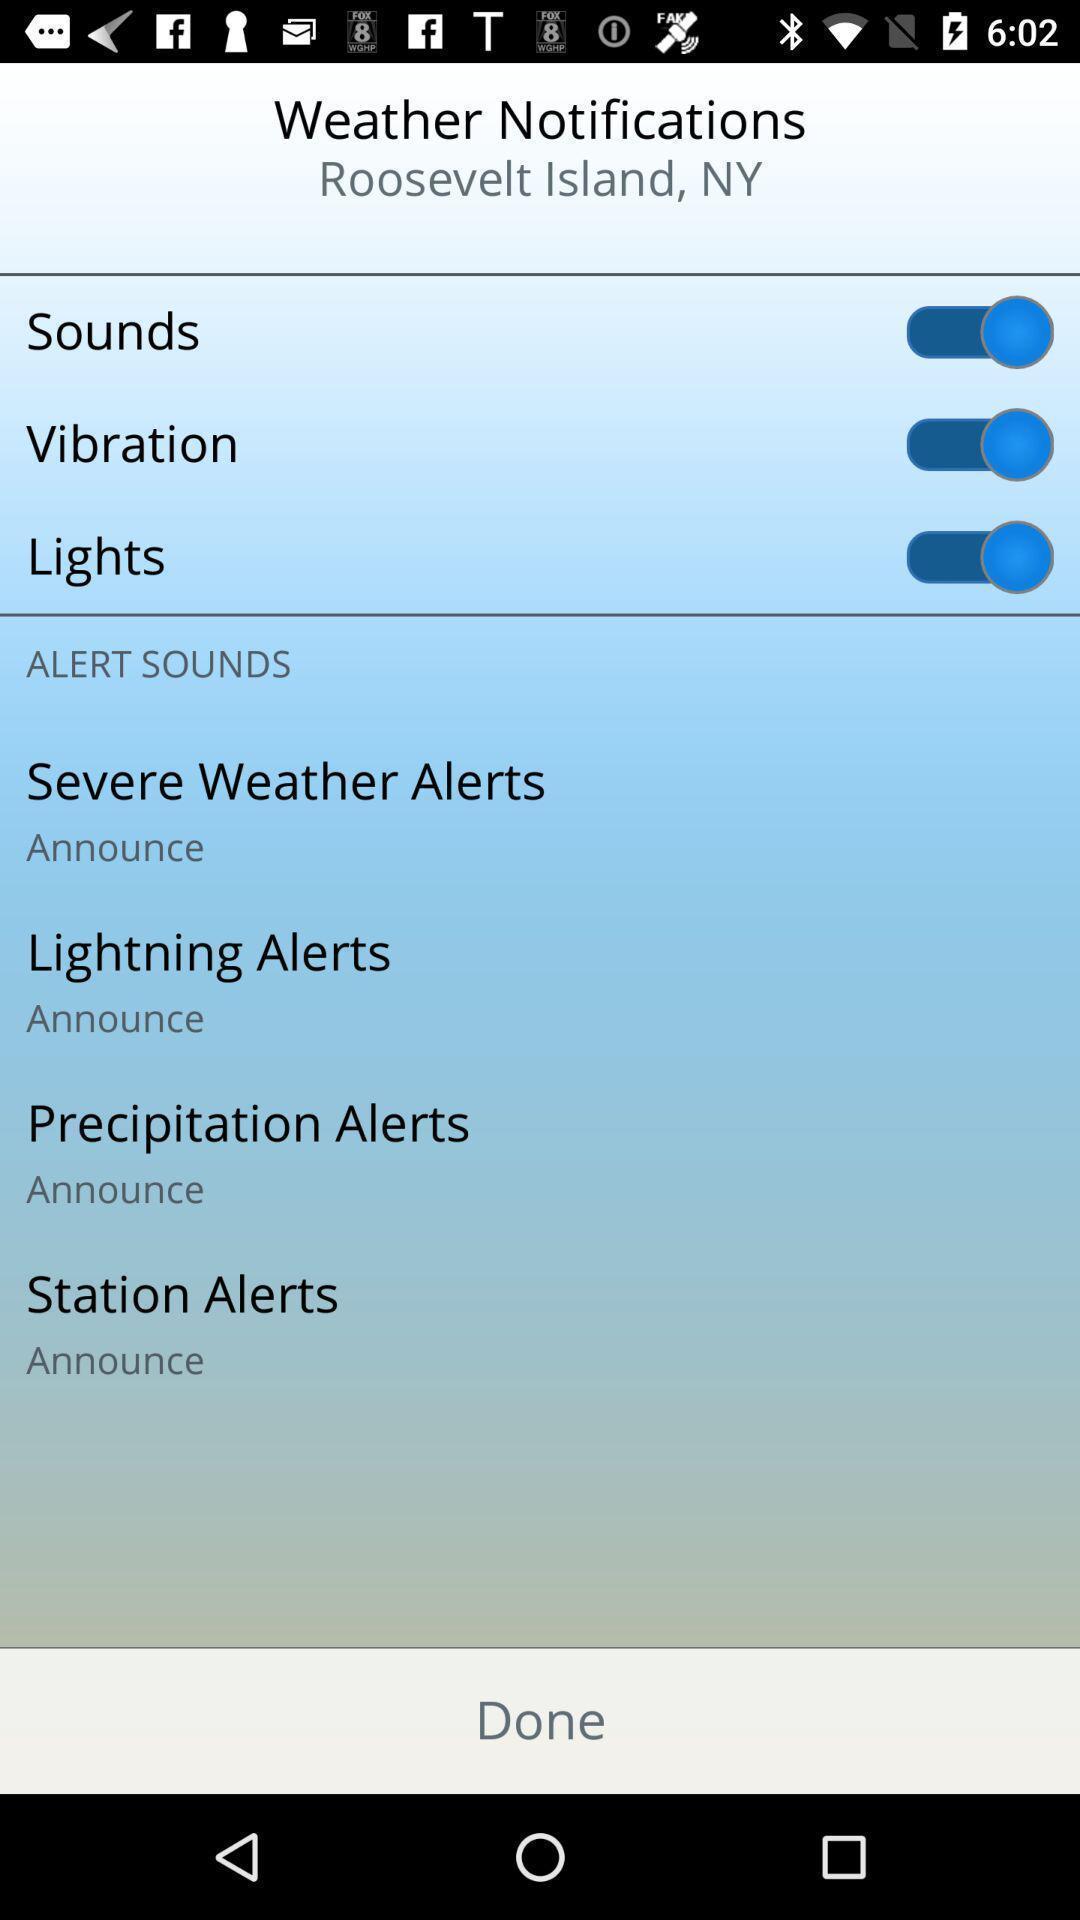Provide a detailed account of this screenshot. Screen page displaying various options in climate application. 